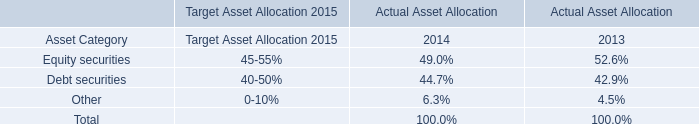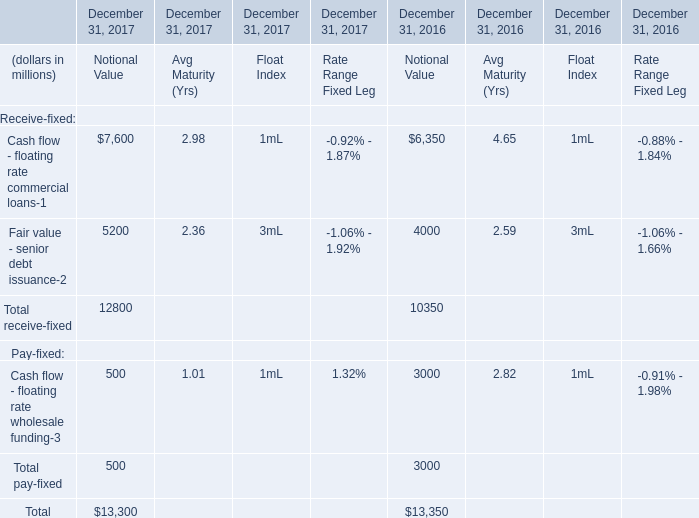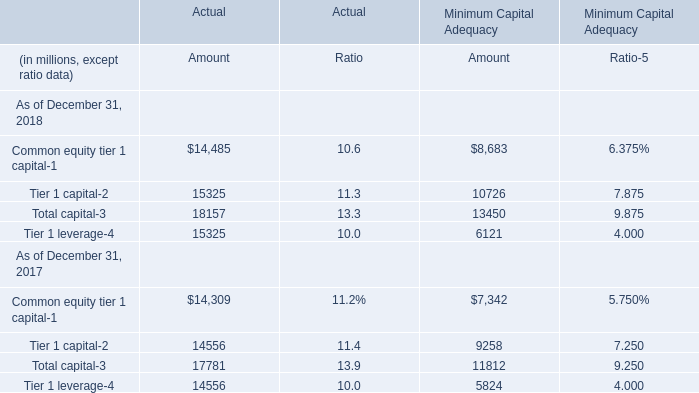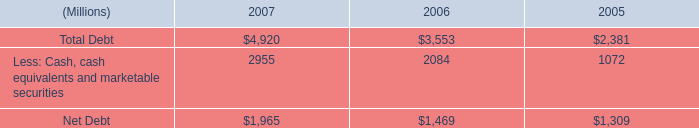What do all Notional Value sum up, excluding those negative ones in 2017? (in million) 
Computations: ((7600 + 5200) + 500)
Answer: 13300.0. 